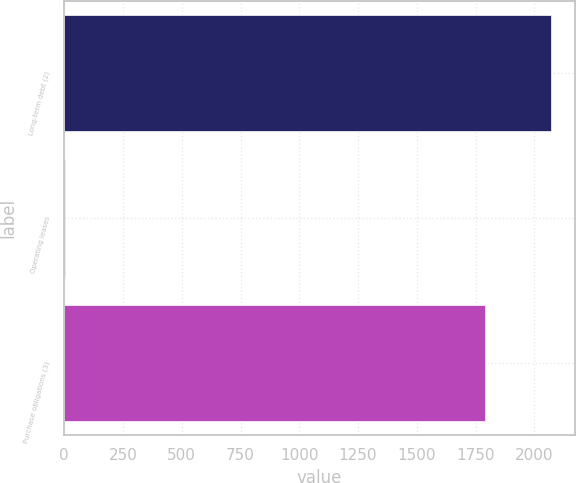<chart> <loc_0><loc_0><loc_500><loc_500><bar_chart><fcel>Long-term debt (2)<fcel>Operating leases<fcel>Purchase obligations (3)<nl><fcel>2070<fcel>5<fcel>1792<nl></chart> 